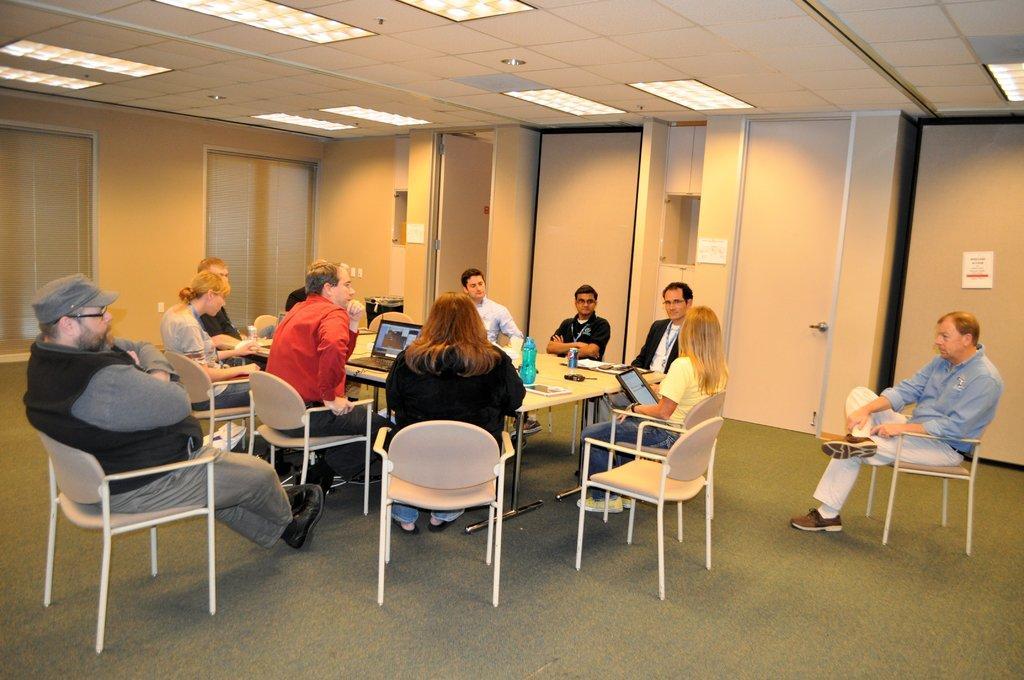Can you describe this image briefly? In this image I see group who are sitting on the chair and there is a table in front and there are few things on it. In the background I see the doors, wall and lights on the ceiling. 